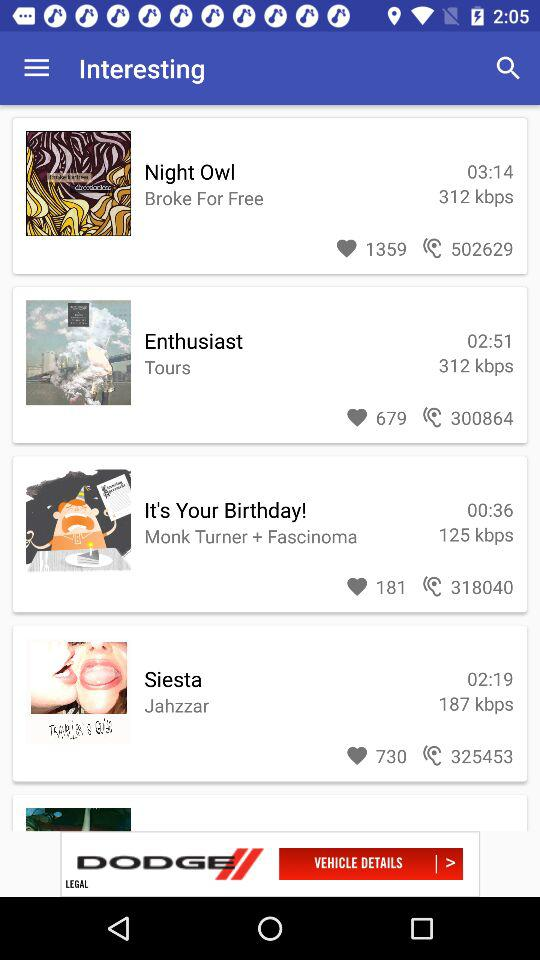How many people listened to "It's your birthday"? There are 318040 people who listened to "It's your birthday". 